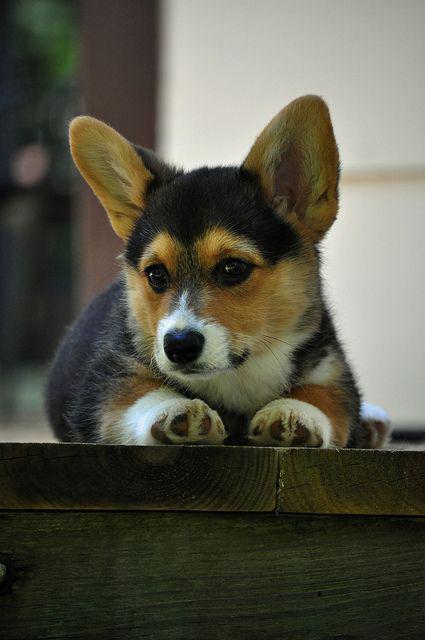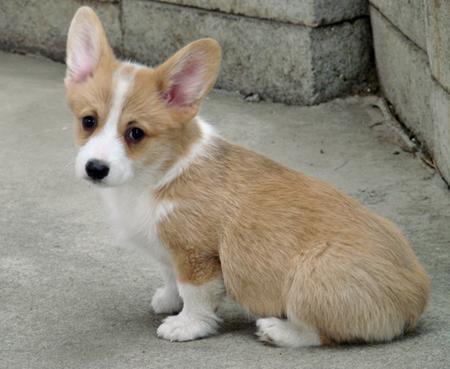The first image is the image on the left, the second image is the image on the right. Evaluate the accuracy of this statement regarding the images: "Each image shows only one dog, with the dog in the right image orange-and-white, and the dog on the left tri-colored.". Is it true? Answer yes or no. Yes. The first image is the image on the left, the second image is the image on the right. Examine the images to the left and right. Is the description "An image contains two dogs." accurate? Answer yes or no. No. 